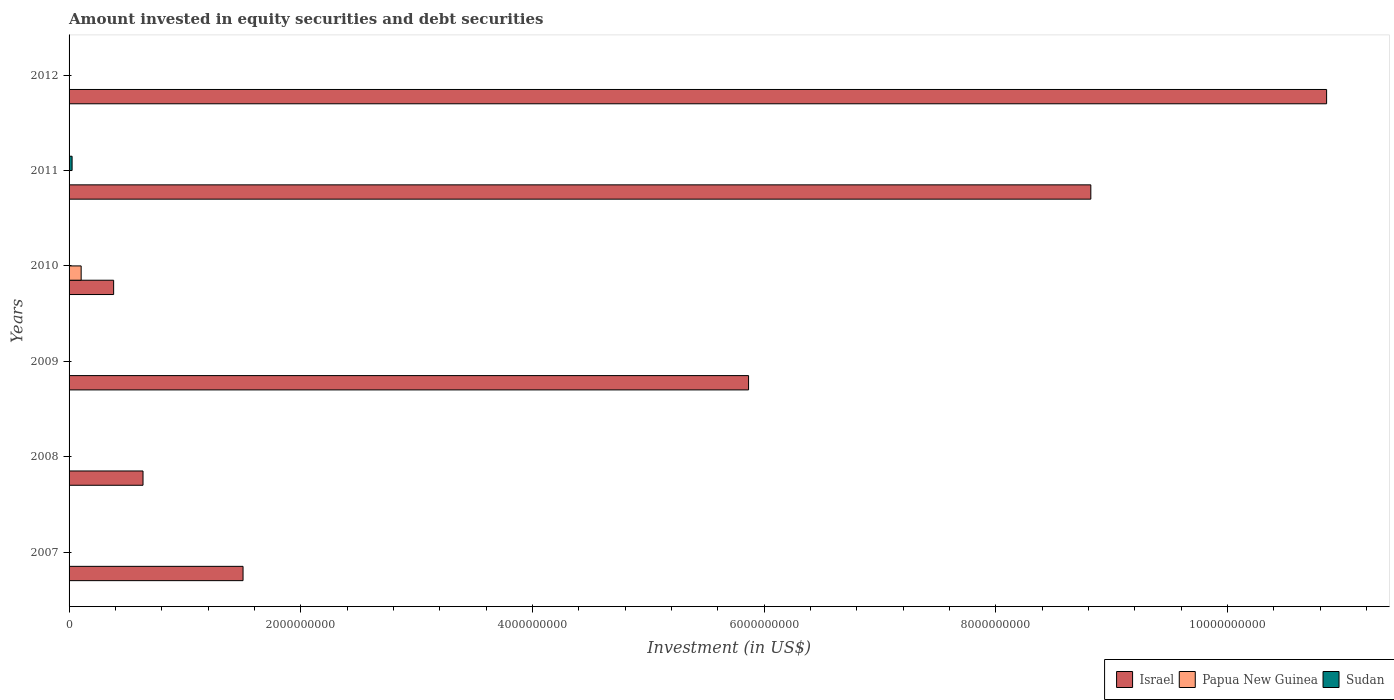Are the number of bars per tick equal to the number of legend labels?
Offer a very short reply. No. How many bars are there on the 4th tick from the bottom?
Ensure brevity in your answer.  2. In how many cases, is the number of bars for a given year not equal to the number of legend labels?
Keep it short and to the point. 6. Across all years, what is the maximum amount invested in equity securities and debt securities in Israel?
Keep it short and to the point. 1.09e+1. Across all years, what is the minimum amount invested in equity securities and debt securities in Israel?
Make the answer very short. 3.85e+08. In which year was the amount invested in equity securities and debt securities in Papua New Guinea maximum?
Your answer should be very brief. 2010. What is the total amount invested in equity securities and debt securities in Papua New Guinea in the graph?
Your answer should be very brief. 1.04e+08. What is the difference between the amount invested in equity securities and debt securities in Israel in 2008 and that in 2012?
Give a very brief answer. -1.02e+1. What is the difference between the amount invested in equity securities and debt securities in Papua New Guinea in 2008 and the amount invested in equity securities and debt securities in Israel in 2012?
Give a very brief answer. -1.09e+1. What is the average amount invested in equity securities and debt securities in Papua New Guinea per year?
Ensure brevity in your answer.  1.74e+07. What is the ratio of the amount invested in equity securities and debt securities in Israel in 2007 to that in 2012?
Provide a succinct answer. 0.14. Is the amount invested in equity securities and debt securities in Israel in 2009 less than that in 2010?
Your answer should be very brief. No. What is the difference between the highest and the second highest amount invested in equity securities and debt securities in Israel?
Make the answer very short. 2.04e+09. What is the difference between the highest and the lowest amount invested in equity securities and debt securities in Israel?
Ensure brevity in your answer.  1.05e+1. Is it the case that in every year, the sum of the amount invested in equity securities and debt securities in Papua New Guinea and amount invested in equity securities and debt securities in Sudan is greater than the amount invested in equity securities and debt securities in Israel?
Ensure brevity in your answer.  No. How many bars are there?
Your answer should be very brief. 8. How many years are there in the graph?
Make the answer very short. 6. Does the graph contain any zero values?
Make the answer very short. Yes. What is the title of the graph?
Offer a terse response. Amount invested in equity securities and debt securities. Does "Ethiopia" appear as one of the legend labels in the graph?
Keep it short and to the point. No. What is the label or title of the X-axis?
Provide a succinct answer. Investment (in US$). What is the Investment (in US$) of Israel in 2007?
Offer a terse response. 1.50e+09. What is the Investment (in US$) in Papua New Guinea in 2007?
Make the answer very short. 0. What is the Investment (in US$) of Israel in 2008?
Your response must be concise. 6.38e+08. What is the Investment (in US$) of Papua New Guinea in 2008?
Provide a short and direct response. 0. What is the Investment (in US$) of Sudan in 2008?
Your answer should be compact. 0. What is the Investment (in US$) of Israel in 2009?
Make the answer very short. 5.86e+09. What is the Investment (in US$) of Israel in 2010?
Provide a succinct answer. 3.85e+08. What is the Investment (in US$) in Papua New Guinea in 2010?
Offer a terse response. 1.04e+08. What is the Investment (in US$) of Sudan in 2010?
Offer a very short reply. 0. What is the Investment (in US$) in Israel in 2011?
Provide a short and direct response. 8.82e+09. What is the Investment (in US$) in Sudan in 2011?
Ensure brevity in your answer.  2.61e+07. What is the Investment (in US$) in Israel in 2012?
Ensure brevity in your answer.  1.09e+1. What is the Investment (in US$) of Sudan in 2012?
Your answer should be very brief. 0. Across all years, what is the maximum Investment (in US$) of Israel?
Provide a succinct answer. 1.09e+1. Across all years, what is the maximum Investment (in US$) of Papua New Guinea?
Ensure brevity in your answer.  1.04e+08. Across all years, what is the maximum Investment (in US$) in Sudan?
Make the answer very short. 2.61e+07. Across all years, what is the minimum Investment (in US$) in Israel?
Provide a short and direct response. 3.85e+08. Across all years, what is the minimum Investment (in US$) of Sudan?
Make the answer very short. 0. What is the total Investment (in US$) of Israel in the graph?
Offer a terse response. 2.81e+1. What is the total Investment (in US$) of Papua New Guinea in the graph?
Offer a terse response. 1.04e+08. What is the total Investment (in US$) of Sudan in the graph?
Your answer should be very brief. 2.61e+07. What is the difference between the Investment (in US$) in Israel in 2007 and that in 2008?
Provide a short and direct response. 8.63e+08. What is the difference between the Investment (in US$) in Israel in 2007 and that in 2009?
Your answer should be very brief. -4.36e+09. What is the difference between the Investment (in US$) in Israel in 2007 and that in 2010?
Give a very brief answer. 1.12e+09. What is the difference between the Investment (in US$) in Israel in 2007 and that in 2011?
Make the answer very short. -7.32e+09. What is the difference between the Investment (in US$) in Israel in 2007 and that in 2012?
Your answer should be compact. -9.35e+09. What is the difference between the Investment (in US$) of Israel in 2008 and that in 2009?
Keep it short and to the point. -5.23e+09. What is the difference between the Investment (in US$) in Israel in 2008 and that in 2010?
Give a very brief answer. 2.54e+08. What is the difference between the Investment (in US$) in Israel in 2008 and that in 2011?
Provide a succinct answer. -8.18e+09. What is the difference between the Investment (in US$) of Israel in 2008 and that in 2012?
Give a very brief answer. -1.02e+1. What is the difference between the Investment (in US$) of Israel in 2009 and that in 2010?
Provide a succinct answer. 5.48e+09. What is the difference between the Investment (in US$) in Israel in 2009 and that in 2011?
Offer a terse response. -2.95e+09. What is the difference between the Investment (in US$) in Israel in 2009 and that in 2012?
Provide a short and direct response. -4.99e+09. What is the difference between the Investment (in US$) of Israel in 2010 and that in 2011?
Ensure brevity in your answer.  -8.43e+09. What is the difference between the Investment (in US$) in Israel in 2010 and that in 2012?
Provide a short and direct response. -1.05e+1. What is the difference between the Investment (in US$) in Israel in 2011 and that in 2012?
Your answer should be very brief. -2.04e+09. What is the difference between the Investment (in US$) of Israel in 2007 and the Investment (in US$) of Papua New Guinea in 2010?
Keep it short and to the point. 1.40e+09. What is the difference between the Investment (in US$) in Israel in 2007 and the Investment (in US$) in Sudan in 2011?
Your response must be concise. 1.48e+09. What is the difference between the Investment (in US$) of Israel in 2008 and the Investment (in US$) of Papua New Guinea in 2010?
Ensure brevity in your answer.  5.34e+08. What is the difference between the Investment (in US$) of Israel in 2008 and the Investment (in US$) of Sudan in 2011?
Keep it short and to the point. 6.12e+08. What is the difference between the Investment (in US$) of Israel in 2009 and the Investment (in US$) of Papua New Guinea in 2010?
Provide a succinct answer. 5.76e+09. What is the difference between the Investment (in US$) of Israel in 2009 and the Investment (in US$) of Sudan in 2011?
Your answer should be compact. 5.84e+09. What is the difference between the Investment (in US$) of Israel in 2010 and the Investment (in US$) of Sudan in 2011?
Offer a very short reply. 3.59e+08. What is the difference between the Investment (in US$) in Papua New Guinea in 2010 and the Investment (in US$) in Sudan in 2011?
Your answer should be very brief. 7.83e+07. What is the average Investment (in US$) in Israel per year?
Offer a terse response. 4.68e+09. What is the average Investment (in US$) in Papua New Guinea per year?
Your answer should be compact. 1.74e+07. What is the average Investment (in US$) in Sudan per year?
Provide a succinct answer. 4.35e+06. In the year 2010, what is the difference between the Investment (in US$) of Israel and Investment (in US$) of Papua New Guinea?
Provide a succinct answer. 2.80e+08. In the year 2011, what is the difference between the Investment (in US$) of Israel and Investment (in US$) of Sudan?
Your answer should be very brief. 8.79e+09. What is the ratio of the Investment (in US$) of Israel in 2007 to that in 2008?
Your answer should be compact. 2.35. What is the ratio of the Investment (in US$) in Israel in 2007 to that in 2009?
Keep it short and to the point. 0.26. What is the ratio of the Investment (in US$) of Israel in 2007 to that in 2010?
Your answer should be very brief. 3.9. What is the ratio of the Investment (in US$) in Israel in 2007 to that in 2011?
Give a very brief answer. 0.17. What is the ratio of the Investment (in US$) of Israel in 2007 to that in 2012?
Provide a short and direct response. 0.14. What is the ratio of the Investment (in US$) in Israel in 2008 to that in 2009?
Keep it short and to the point. 0.11. What is the ratio of the Investment (in US$) of Israel in 2008 to that in 2010?
Make the answer very short. 1.66. What is the ratio of the Investment (in US$) of Israel in 2008 to that in 2011?
Ensure brevity in your answer.  0.07. What is the ratio of the Investment (in US$) in Israel in 2008 to that in 2012?
Give a very brief answer. 0.06. What is the ratio of the Investment (in US$) of Israel in 2009 to that in 2010?
Give a very brief answer. 15.25. What is the ratio of the Investment (in US$) in Israel in 2009 to that in 2011?
Ensure brevity in your answer.  0.67. What is the ratio of the Investment (in US$) of Israel in 2009 to that in 2012?
Your answer should be compact. 0.54. What is the ratio of the Investment (in US$) of Israel in 2010 to that in 2011?
Your answer should be compact. 0.04. What is the ratio of the Investment (in US$) of Israel in 2010 to that in 2012?
Your answer should be very brief. 0.04. What is the ratio of the Investment (in US$) in Israel in 2011 to that in 2012?
Your response must be concise. 0.81. What is the difference between the highest and the second highest Investment (in US$) of Israel?
Provide a short and direct response. 2.04e+09. What is the difference between the highest and the lowest Investment (in US$) in Israel?
Offer a terse response. 1.05e+1. What is the difference between the highest and the lowest Investment (in US$) in Papua New Guinea?
Provide a short and direct response. 1.04e+08. What is the difference between the highest and the lowest Investment (in US$) in Sudan?
Ensure brevity in your answer.  2.61e+07. 